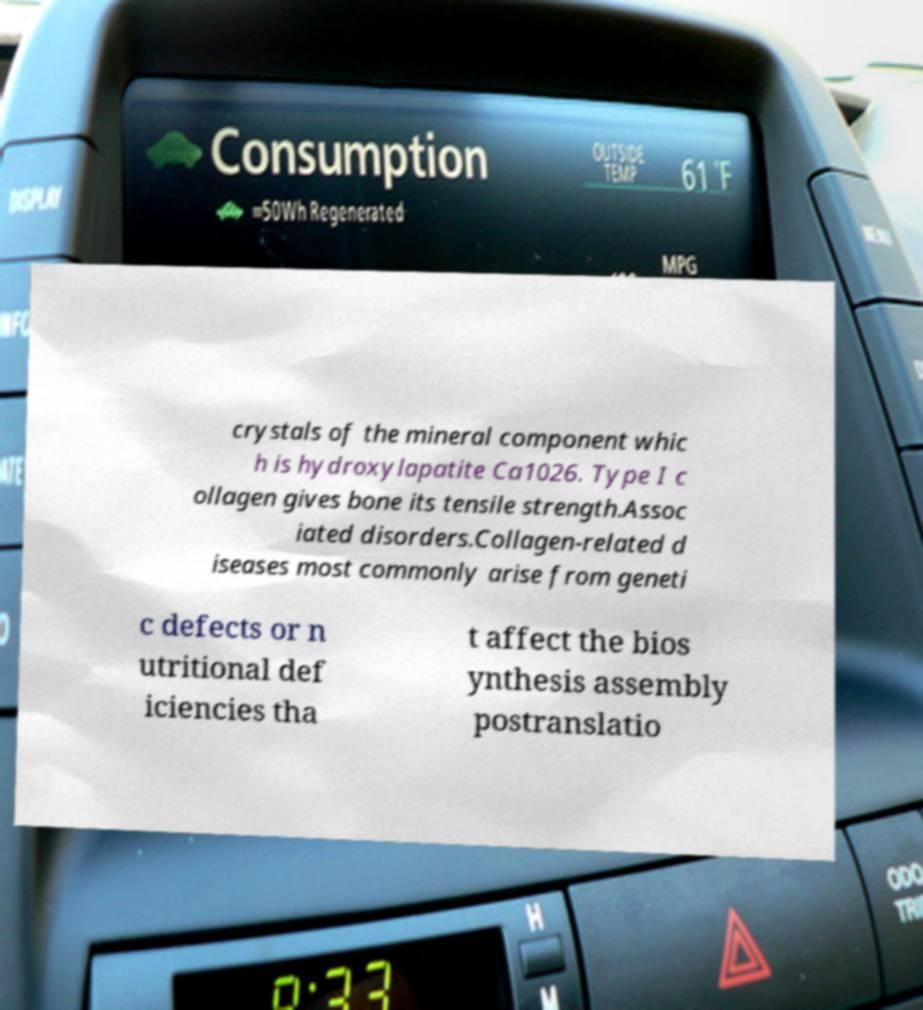I need the written content from this picture converted into text. Can you do that? crystals of the mineral component whic h is hydroxylapatite Ca1026. Type I c ollagen gives bone its tensile strength.Assoc iated disorders.Collagen-related d iseases most commonly arise from geneti c defects or n utritional def iciencies tha t affect the bios ynthesis assembly postranslatio 